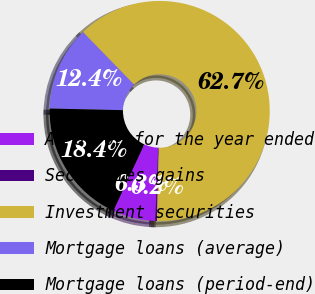Convert chart to OTSL. <chart><loc_0><loc_0><loc_500><loc_500><pie_chart><fcel>As of or for the year ended<fcel>Securities gains<fcel>Investment securities<fcel>Mortgage loans (average)<fcel>Mortgage loans (period-end)<nl><fcel>6.3%<fcel>0.24%<fcel>62.68%<fcel>12.36%<fcel>18.42%<nl></chart> 